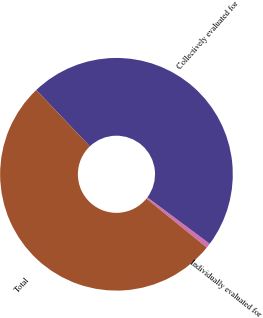Convert chart. <chart><loc_0><loc_0><loc_500><loc_500><pie_chart><fcel>Individually evaluated for<fcel>Collectively evaluated for<fcel>Total<nl><fcel>0.66%<fcel>47.31%<fcel>52.04%<nl></chart> 